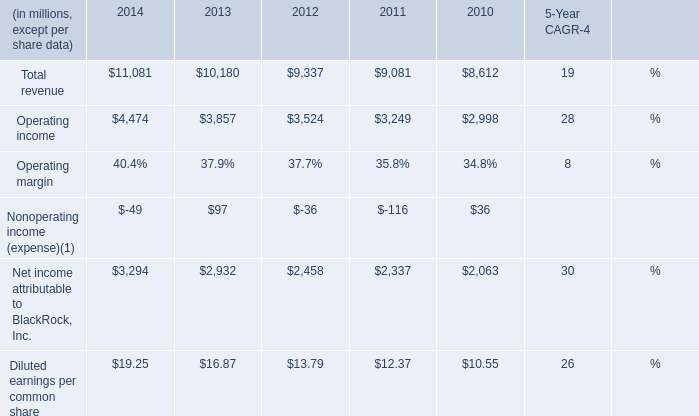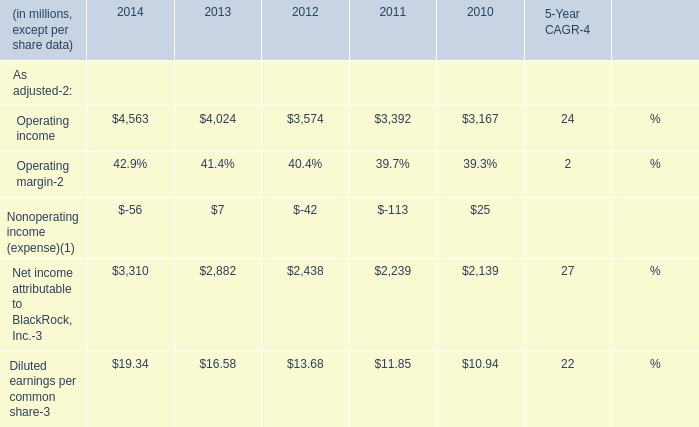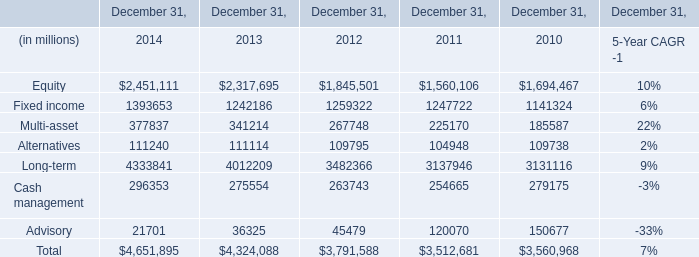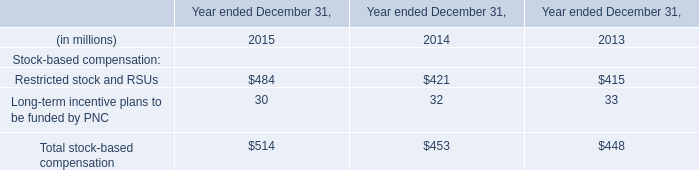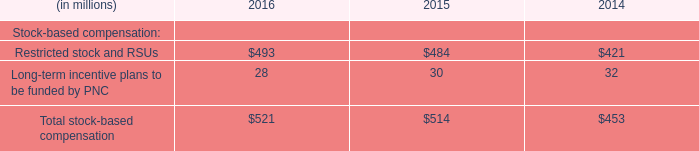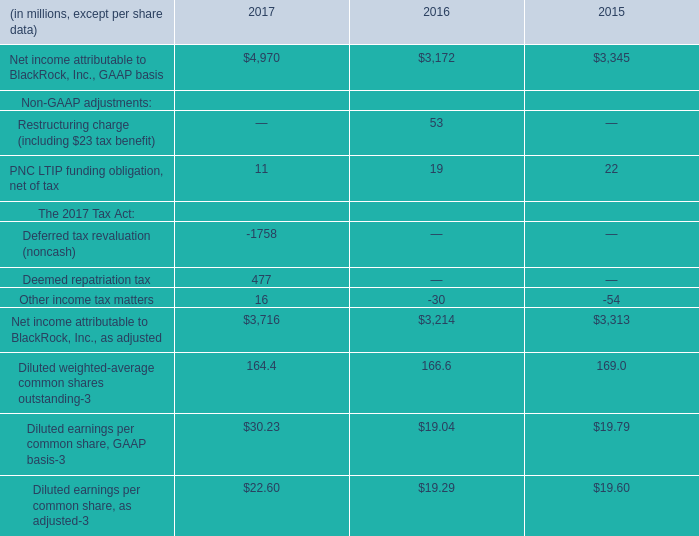What will Operating income reach in 2015 if it continues to grow at its current rate? (in million) 
Computations: ((((4474 - 3857) / 3857) * 4474) + 4474)
Answer: 5189.7008. 